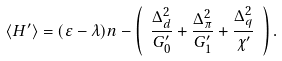Convert formula to latex. <formula><loc_0><loc_0><loc_500><loc_500>\langle H ^ { \prime } \rangle = ( \varepsilon - \lambda ) n - \left ( \ \frac { \Delta _ { d } ^ { 2 } } { G ^ { \prime } _ { 0 } } + \frac { \Delta _ { \pi } ^ { 2 } } { G ^ { \prime } _ { 1 } } + \frac { \Delta _ { q } ^ { 2 } } { \chi ^ { \prime } } \ \right ) .</formula> 